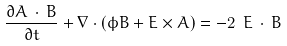<formula> <loc_0><loc_0><loc_500><loc_500>\frac { \partial { A } \, \cdot \, { B } } { \partial t } + \nabla \cdot \left ( \phi { B } + { E } \times { A } \right ) = - 2 \ { E } \, \cdot \, { B }</formula> 